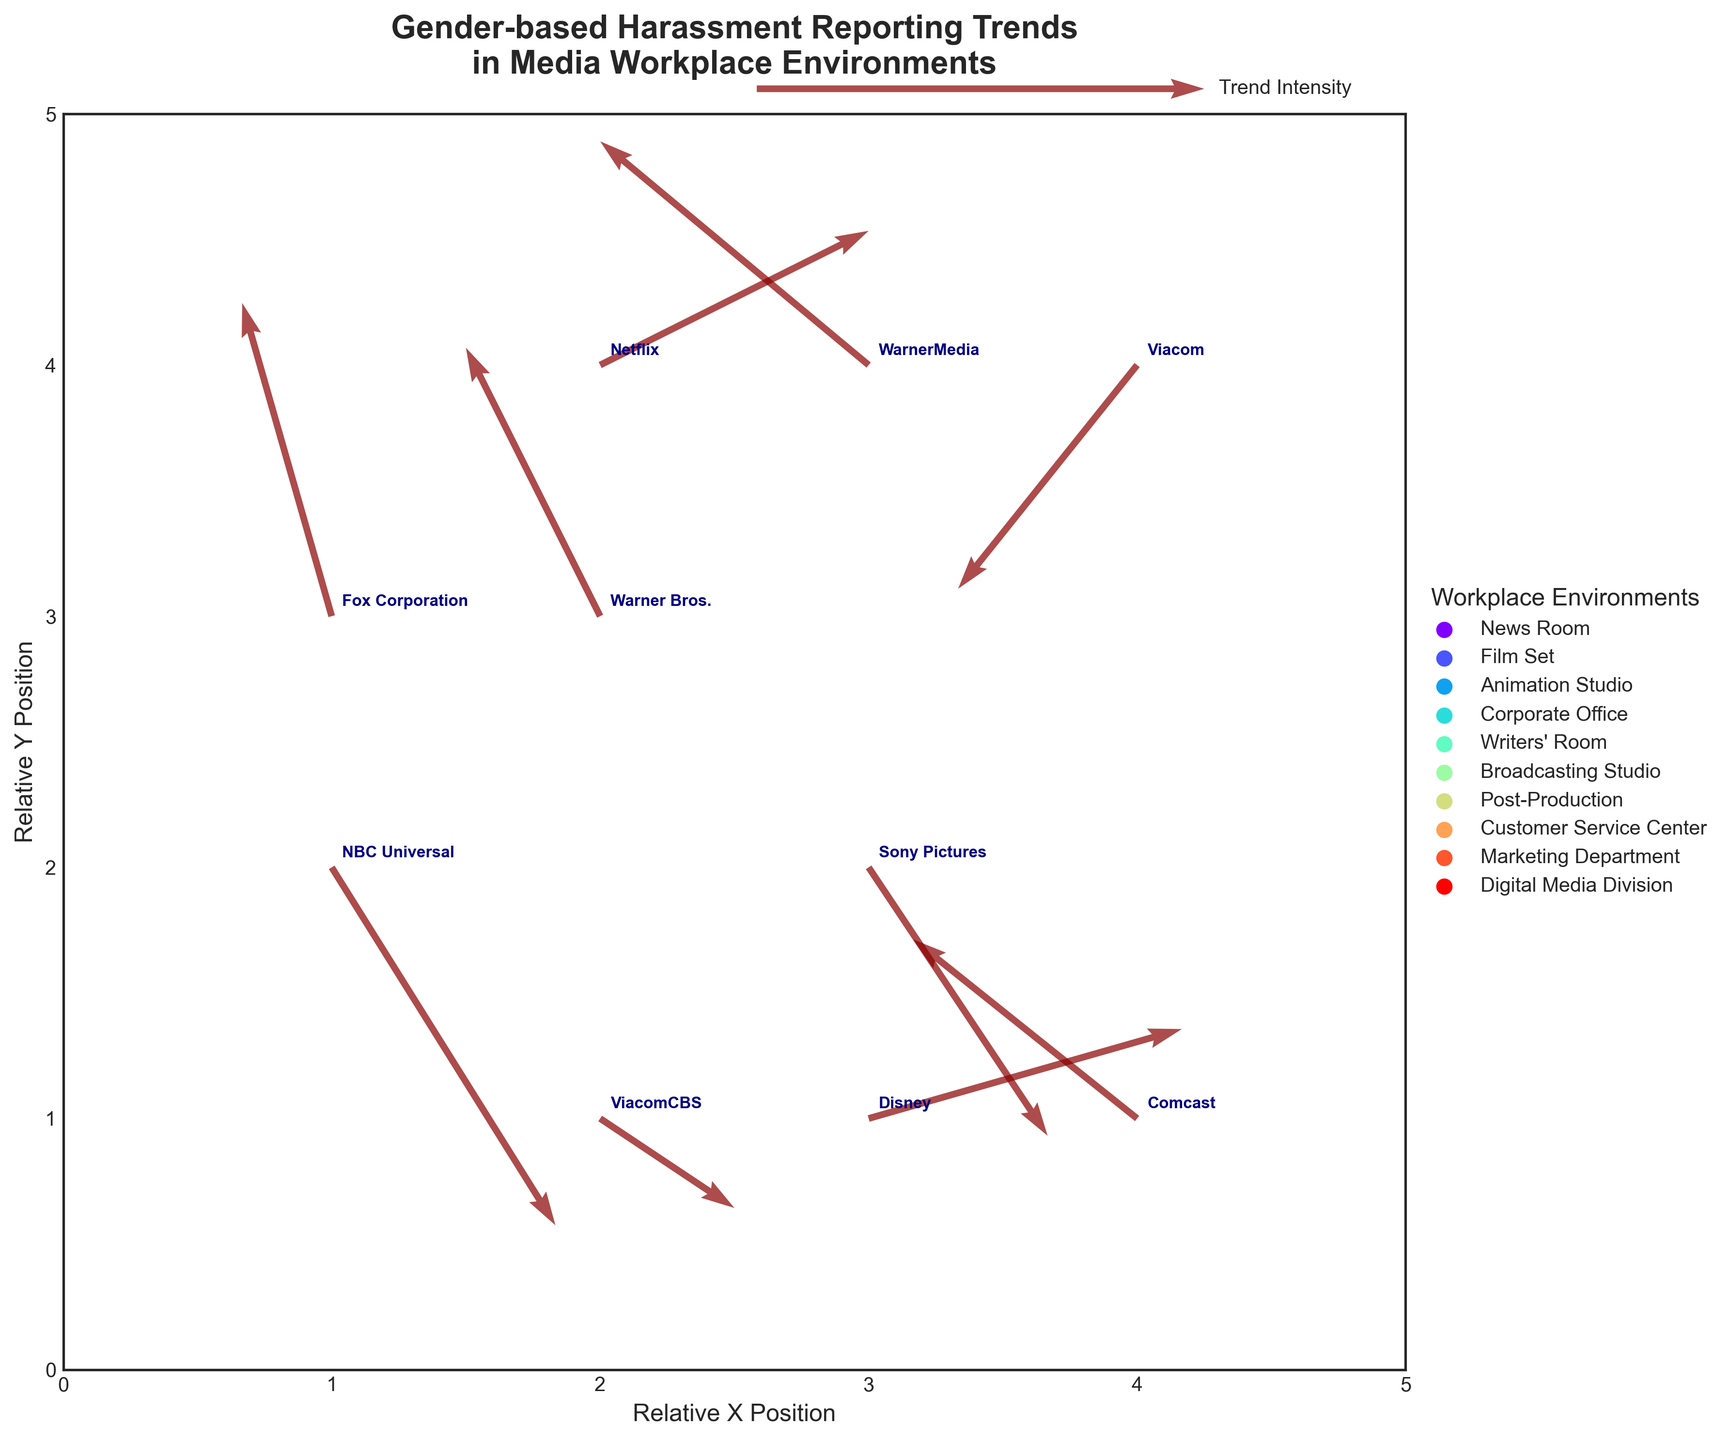What's the title of the figure? The title is displayed at the top of the figure.
Answer: Gender-based Harassment Reporting Trends in Media Workplace Environments How many companies are represented in the figure? Each company name is annotated at data points in the figure.
Answer: 10 What is the lowest Y position any data point occupies? The Y-axis ranges from 0 to 5, and the data points show their Y positions. The lowest Y position is the minimum Y value among the data points.
Answer: 1 Which company shows the highest positive trend in harassment reporting? The highest positive trend can be identified by the length and direction of the quiver arrows pointing upwards and right. Compare the U and V values to find the largest combination.
Answer: Disney Which workplace environment has the most positive trend (U and V combined)? Analyze the quiver arrows' directions and magnitudes, and check which environment has arrows pointing upwards and right. Sum up the U and V components for each environment to determine the maximum combined trend.
Answer: Animation Studio Which company has the most negative trend in U direction? Look for the quiver arrow which has the largest negative value in the U component, indicating a leftward direction.
Answer: WarnerMedia Compare Netflix and Viacom. Which has a greater positive Y-component in their trend? Compare the V values for Netflix and Viacom. The greater positive Y-component will have a higher V value.
Answer: Viacom Describe the trend direction for Fox Corporation's reporting in terms of compass directions (e.g., North, South-East). Check the quiver arrow for Fox Corporation, analyze its U and V values to determine the direction. Positive V and negative U indicate the trend.
Answer: North-West If you combine the trends of Warner Bros. and WarnerMedia, what would be the resultant U and V components? Add the U and V values for both companies to get the resultant trend. Warner Bros. (U=-0.3, V=0.6) and WarnerMedia (U=-0.6, V=0.5). Resultant U = -0.3 + (-0.6) and V = 0.6 + 0.5.
Answer: U=-0.9, V=1.1 Which environment sees a prominent downward trend in reporting, and which company is associated with it? Look for the quiver arrows pointing downwards significantly, indicating a large negative V value. Identify the environment and the associated company at that point.
Answer: Broadcasting Studio (Fox Corporation) 